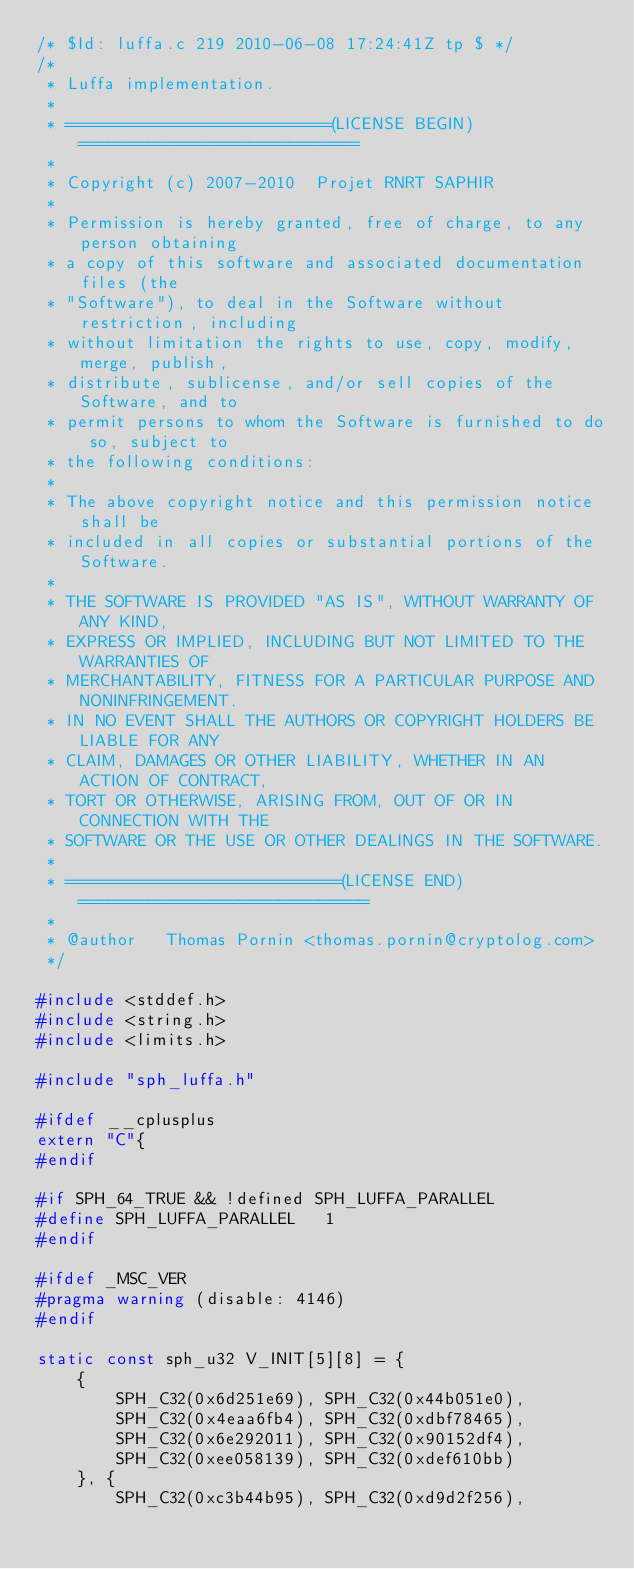<code> <loc_0><loc_0><loc_500><loc_500><_C_>/* $Id: luffa.c 219 2010-06-08 17:24:41Z tp $ */
/*
 * Luffa implementation.
 *
 * ==========================(LICENSE BEGIN)============================
 *
 * Copyright (c) 2007-2010  Projet RNRT SAPHIR
 *
 * Permission is hereby granted, free of charge, to any person obtaining
 * a copy of this software and associated documentation files (the
 * "Software"), to deal in the Software without restriction, including
 * without limitation the rights to use, copy, modify, merge, publish,
 * distribute, sublicense, and/or sell copies of the Software, and to
 * permit persons to whom the Software is furnished to do so, subject to
 * the following conditions:
 *
 * The above copyright notice and this permission notice shall be
 * included in all copies or substantial portions of the Software.
 *
 * THE SOFTWARE IS PROVIDED "AS IS", WITHOUT WARRANTY OF ANY KIND,
 * EXPRESS OR IMPLIED, INCLUDING BUT NOT LIMITED TO THE WARRANTIES OF
 * MERCHANTABILITY, FITNESS FOR A PARTICULAR PURPOSE AND NONINFRINGEMENT.
 * IN NO EVENT SHALL THE AUTHORS OR COPYRIGHT HOLDERS BE LIABLE FOR ANY
 * CLAIM, DAMAGES OR OTHER LIABILITY, WHETHER IN AN ACTION OF CONTRACT,
 * TORT OR OTHERWISE, ARISING FROM, OUT OF OR IN CONNECTION WITH THE
 * SOFTWARE OR THE USE OR OTHER DEALINGS IN THE SOFTWARE.
 *
 * ===========================(LICENSE END)=============================
 *
 * @author   Thomas Pornin <thomas.pornin@cryptolog.com>
 */

#include <stddef.h>
#include <string.h>
#include <limits.h>

#include "sph_luffa.h"

#ifdef __cplusplus
extern "C"{
#endif

#if SPH_64_TRUE && !defined SPH_LUFFA_PARALLEL
#define SPH_LUFFA_PARALLEL   1
#endif

#ifdef _MSC_VER
#pragma warning (disable: 4146)
#endif

static const sph_u32 V_INIT[5][8] = {
    {
        SPH_C32(0x6d251e69), SPH_C32(0x44b051e0),
        SPH_C32(0x4eaa6fb4), SPH_C32(0xdbf78465),
        SPH_C32(0x6e292011), SPH_C32(0x90152df4),
        SPH_C32(0xee058139), SPH_C32(0xdef610bb)
    }, {
        SPH_C32(0xc3b44b95), SPH_C32(0xd9d2f256),</code> 